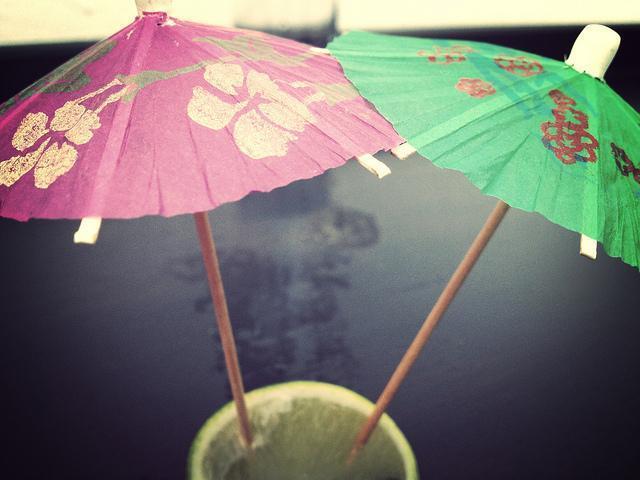How many umbrellas are there?
Give a very brief answer. 2. 